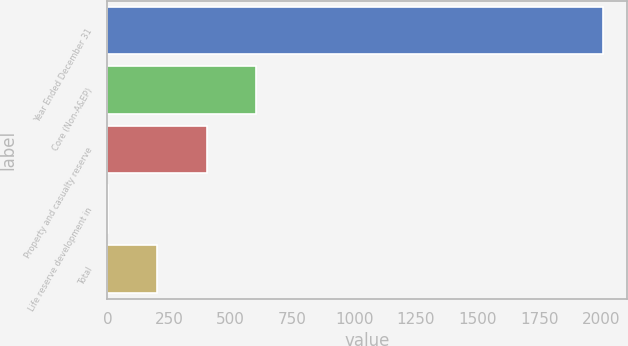Convert chart to OTSL. <chart><loc_0><loc_0><loc_500><loc_500><bar_chart><fcel>Year Ended December 31<fcel>Core (Non-A&EP)<fcel>Property and casualty reserve<fcel>Life reserve development in<fcel>Total<nl><fcel>2008<fcel>603.8<fcel>403.2<fcel>2<fcel>202.6<nl></chart> 